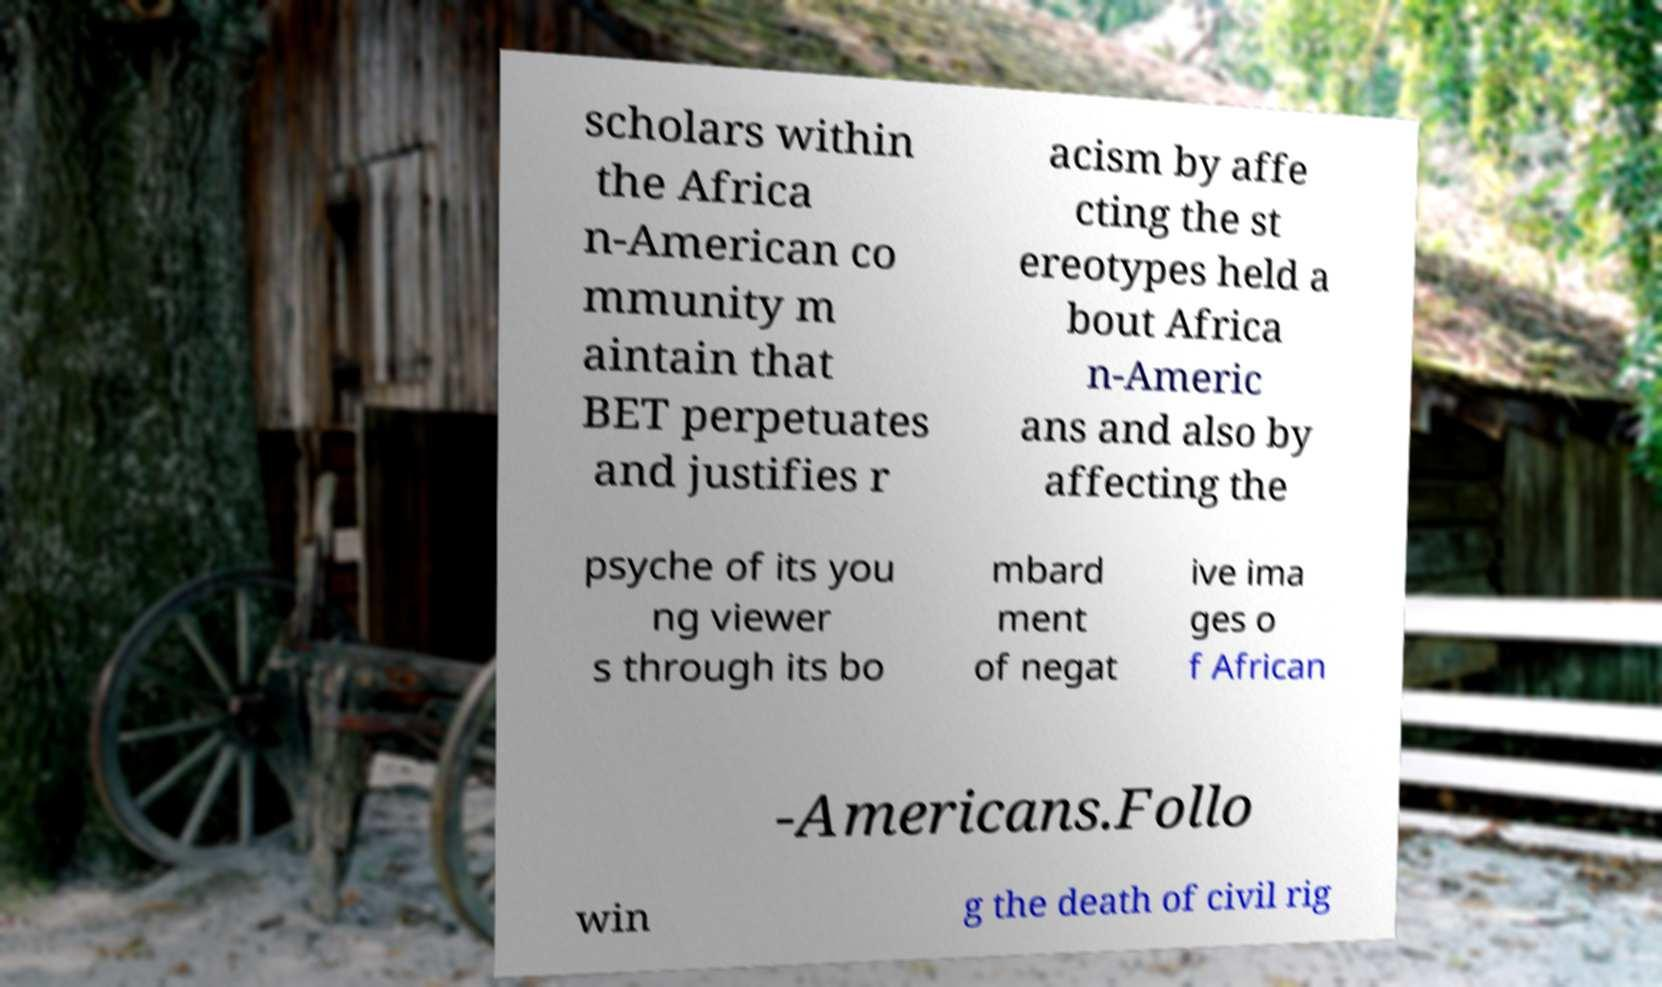For documentation purposes, I need the text within this image transcribed. Could you provide that? scholars within the Africa n-American co mmunity m aintain that BET perpetuates and justifies r acism by affe cting the st ereotypes held a bout Africa n-Americ ans and also by affecting the psyche of its you ng viewer s through its bo mbard ment of negat ive ima ges o f African -Americans.Follo win g the death of civil rig 